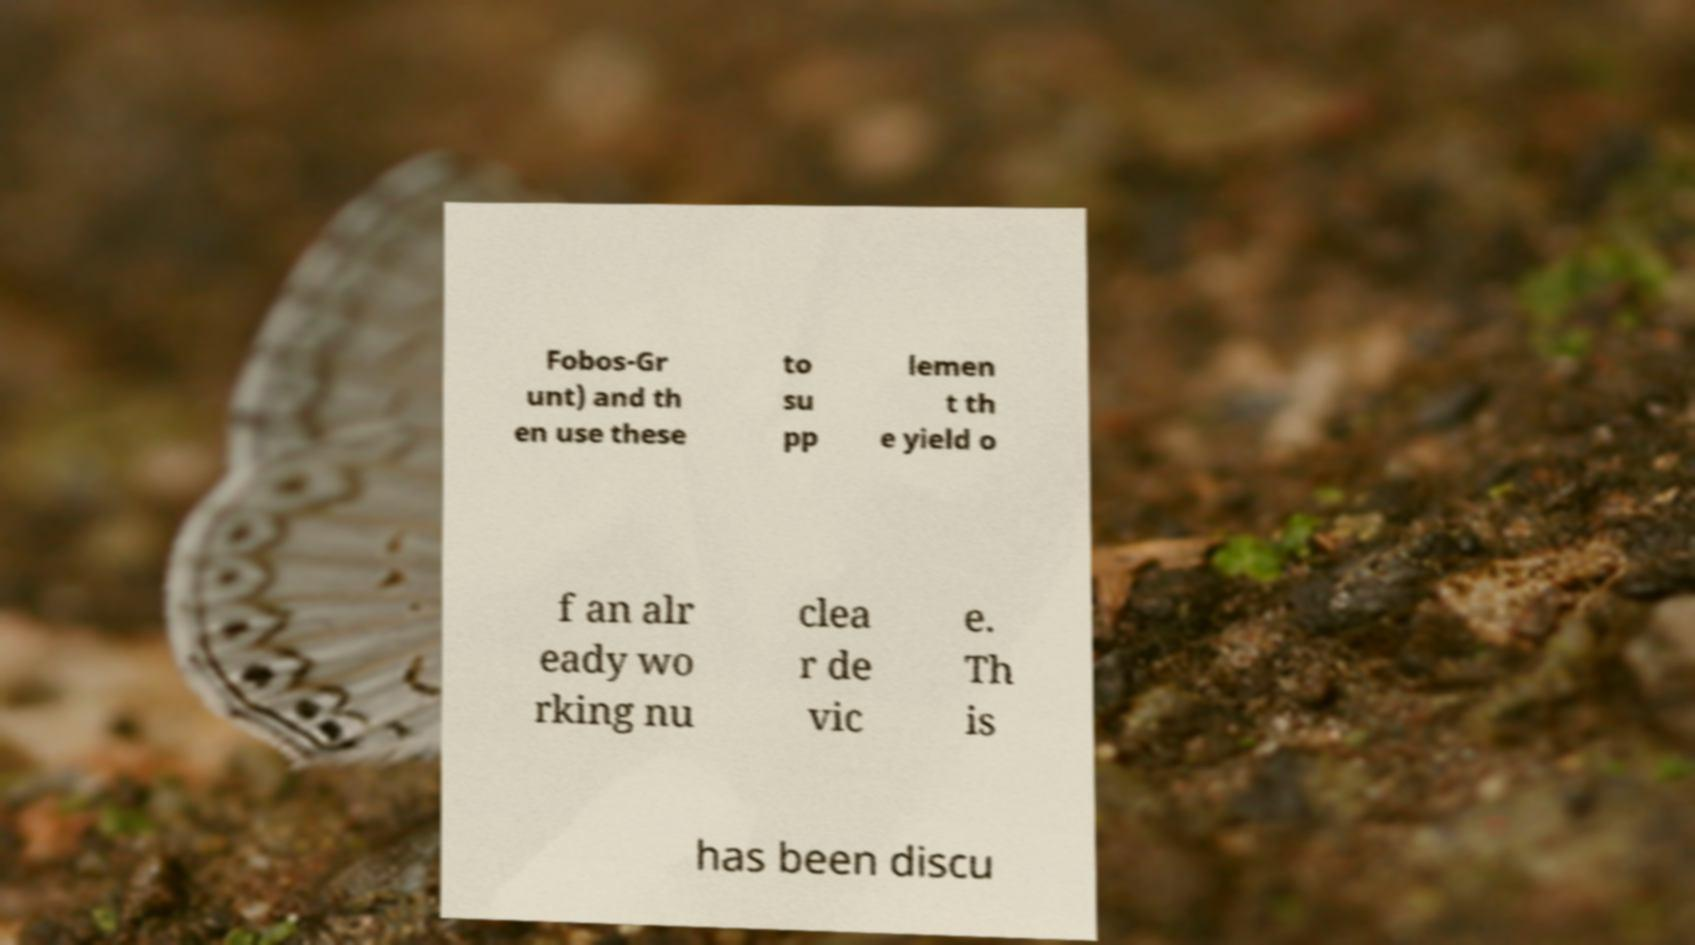Please read and relay the text visible in this image. What does it say? Fobos-Gr unt) and th en use these to su pp lemen t th e yield o f an alr eady wo rking nu clea r de vic e. Th is has been discu 